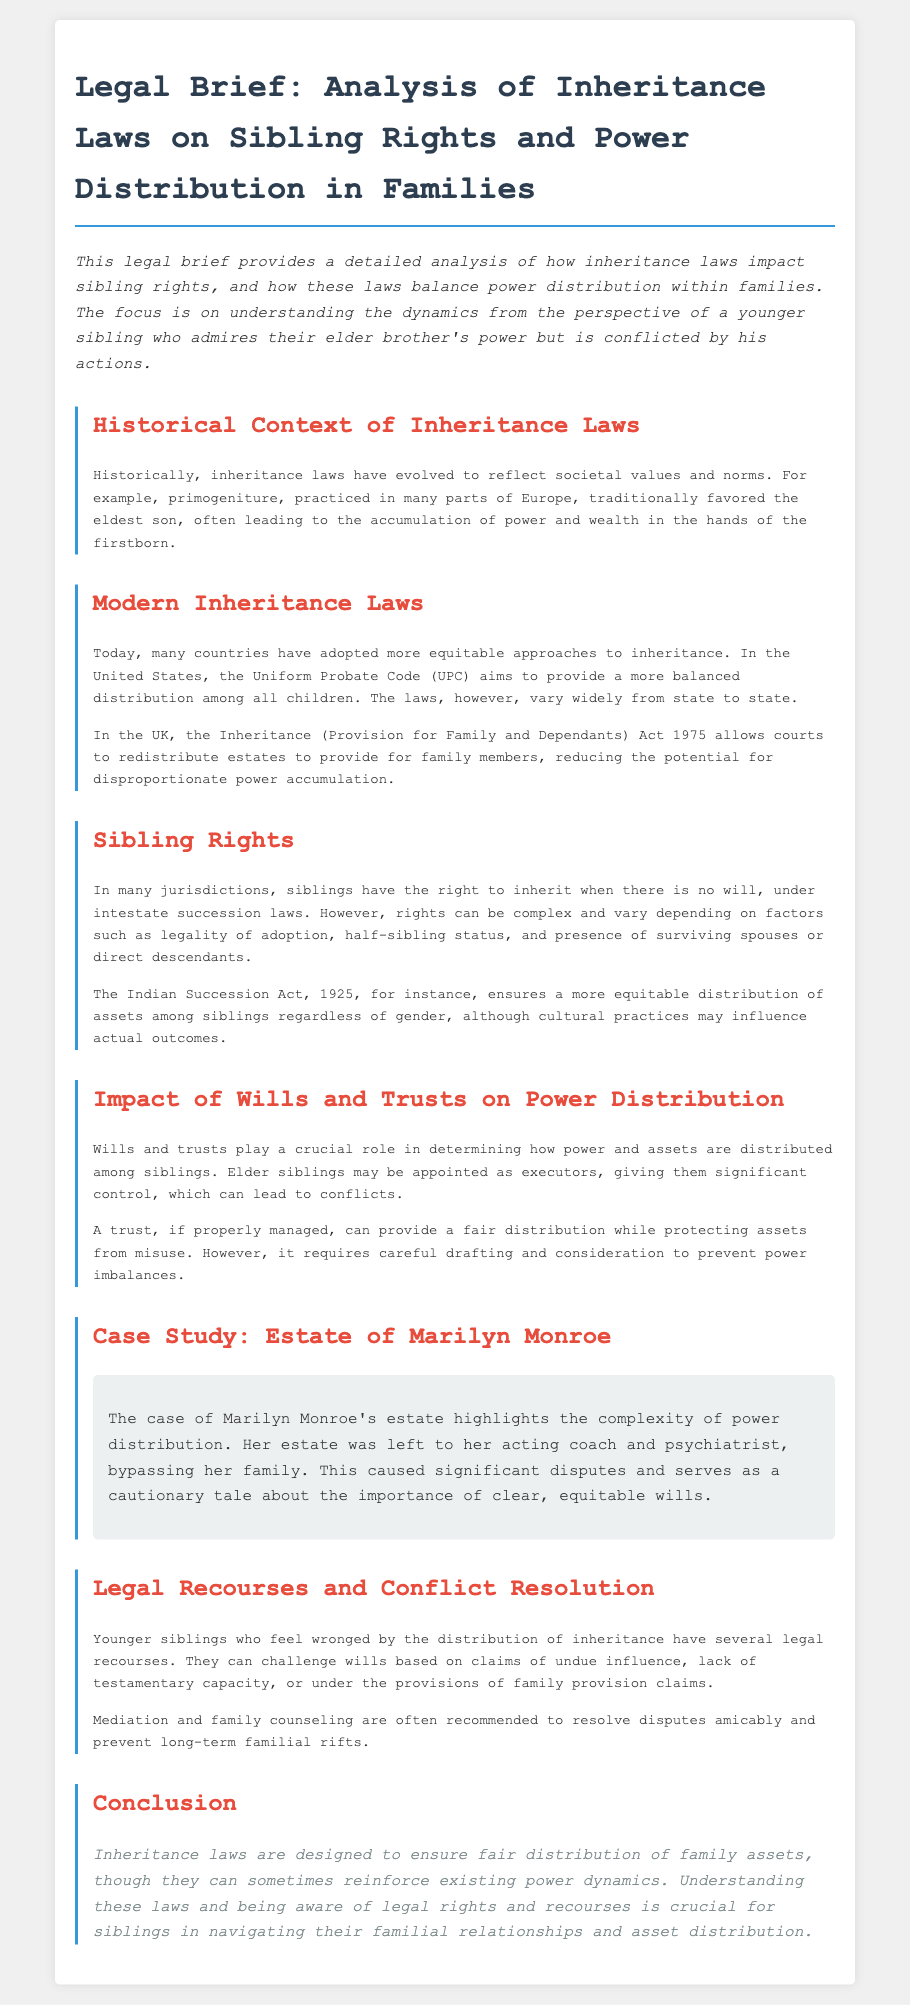What is the title of the legal brief? The title indicates the main subject of the document, which is "Legal Brief: Analysis of Inheritance Laws on Sibling Rights and Power Distribution in Families."
Answer: Legal Brief: Analysis of Inheritance Laws on Sibling Rights and Power Distribution in Families What does the Inheritance (Provision for Family and Dependants) Act 1975 allow? This act allows courts to redistribute estates to provide for family members, which reduces the potential for disproportionate power accumulation.
Answer: Redistribute estates According to the document, what historical practice favored the eldest son? The document mentions a specific practice from history that is related to inheritance laws.
Answer: Primogeniture What act ensures equitable distribution of assets among siblings in India? The act mentioned in the document refers to the legal framework that governs inheritance in India.
Answer: Indian Succession Act, 1925 In the case of Marilyn Monroe, where was her estate left? The document details that her estate was left to specific individuals, bypassing her family.
Answer: Acting coach and psychiatrist What is often recommended to resolve disputes amicably according to the brief? The document highlights a couple of approaches to resolve conflicts regarding inheritance.
Answer: Mediation and family counseling What kind of influence can siblings claim when challenging wills? The document specifies a type of influence that can be considered when disputing a will.
Answer: Undue influence What may elder siblings appointed as executors have significant control over? The role of executors is discussed in the context of power distribution and conflict.
Answer: Distribution of assets 